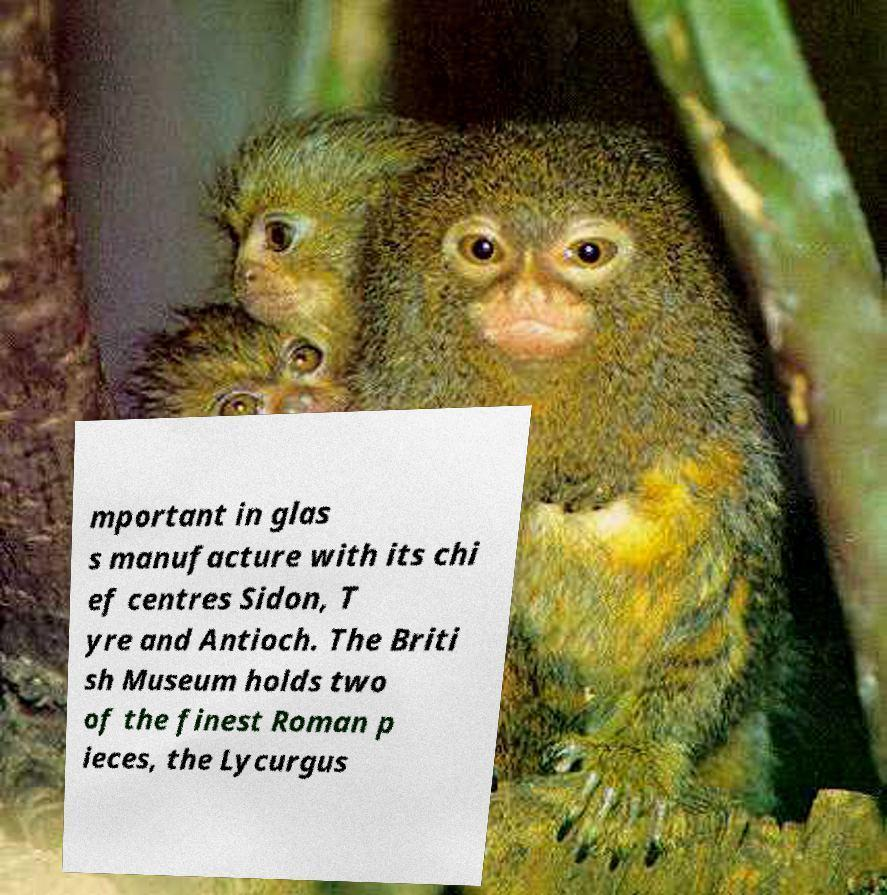Can you read and provide the text displayed in the image?This photo seems to have some interesting text. Can you extract and type it out for me? mportant in glas s manufacture with its chi ef centres Sidon, T yre and Antioch. The Briti sh Museum holds two of the finest Roman p ieces, the Lycurgus 